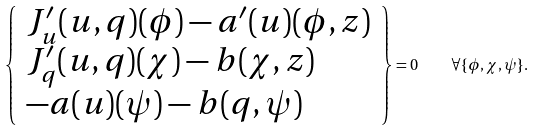Convert formula to latex. <formula><loc_0><loc_0><loc_500><loc_500>\left \{ \begin{array} { l } J _ { u } ^ { \prime } ( u , q ) ( \phi ) - a ^ { \prime } ( u ) ( \phi , z ) \\ J _ { q } ^ { \prime } ( u , q ) ( \chi ) - b ( \chi , z ) \\ - a ( u ) ( \psi ) - b ( q , \psi ) \end{array} \right \} = 0 \quad \forall \{ \phi , \chi , \psi \} .</formula> 